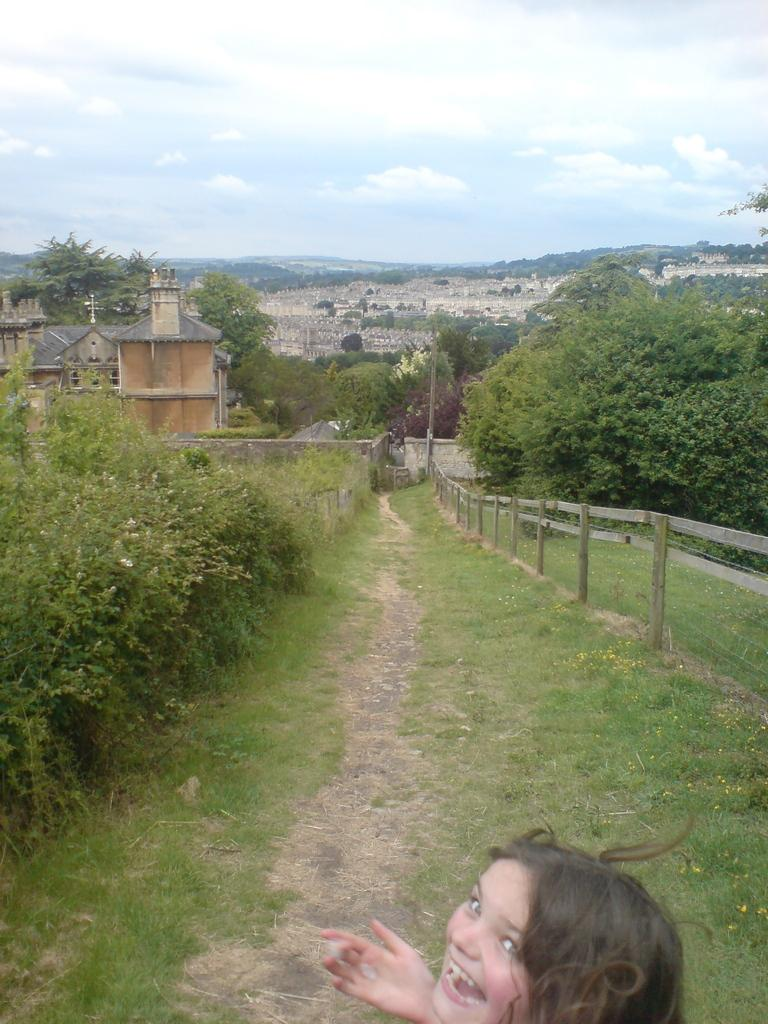Who is present in the image? There is a girl in the image. What type of natural environment is visible in the image? There is grass and plants in the image. What can be seen in the background of the image? There are buildings, trees, sky, and clouds visible in the background of the image. What type of island can be seen in the background of the image? There is no island present in the image. What is the girl holding in her hand, and is it related to the pickle? The girl is not holding a pickle or any object related to a pickle in the image. 